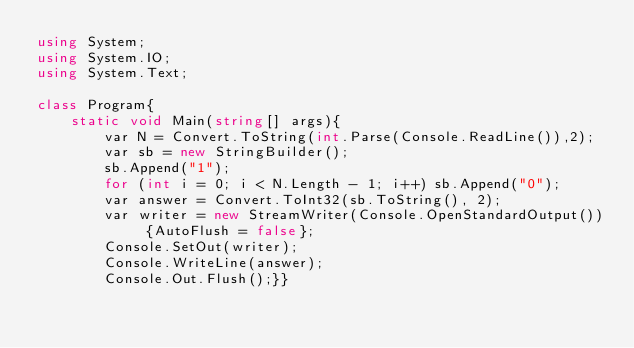Convert code to text. <code><loc_0><loc_0><loc_500><loc_500><_C#_>using System;
using System.IO;
using System.Text;

class Program{
    static void Main(string[] args){
        var N = Convert.ToString(int.Parse(Console.ReadLine()),2);
        var sb = new StringBuilder();
        sb.Append("1");
        for (int i = 0; i < N.Length - 1; i++) sb.Append("0");
        var answer = Convert.ToInt32(sb.ToString(), 2);
        var writer = new StreamWriter(Console.OpenStandardOutput()) {AutoFlush = false};
        Console.SetOut(writer);
        Console.WriteLine(answer);
        Console.Out.Flush();}}</code> 